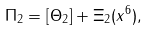Convert formula to latex. <formula><loc_0><loc_0><loc_500><loc_500>\Pi _ { 2 } = [ \Theta _ { 2 } ] + \Xi _ { 2 } ( x ^ { 6 } ) ,</formula> 